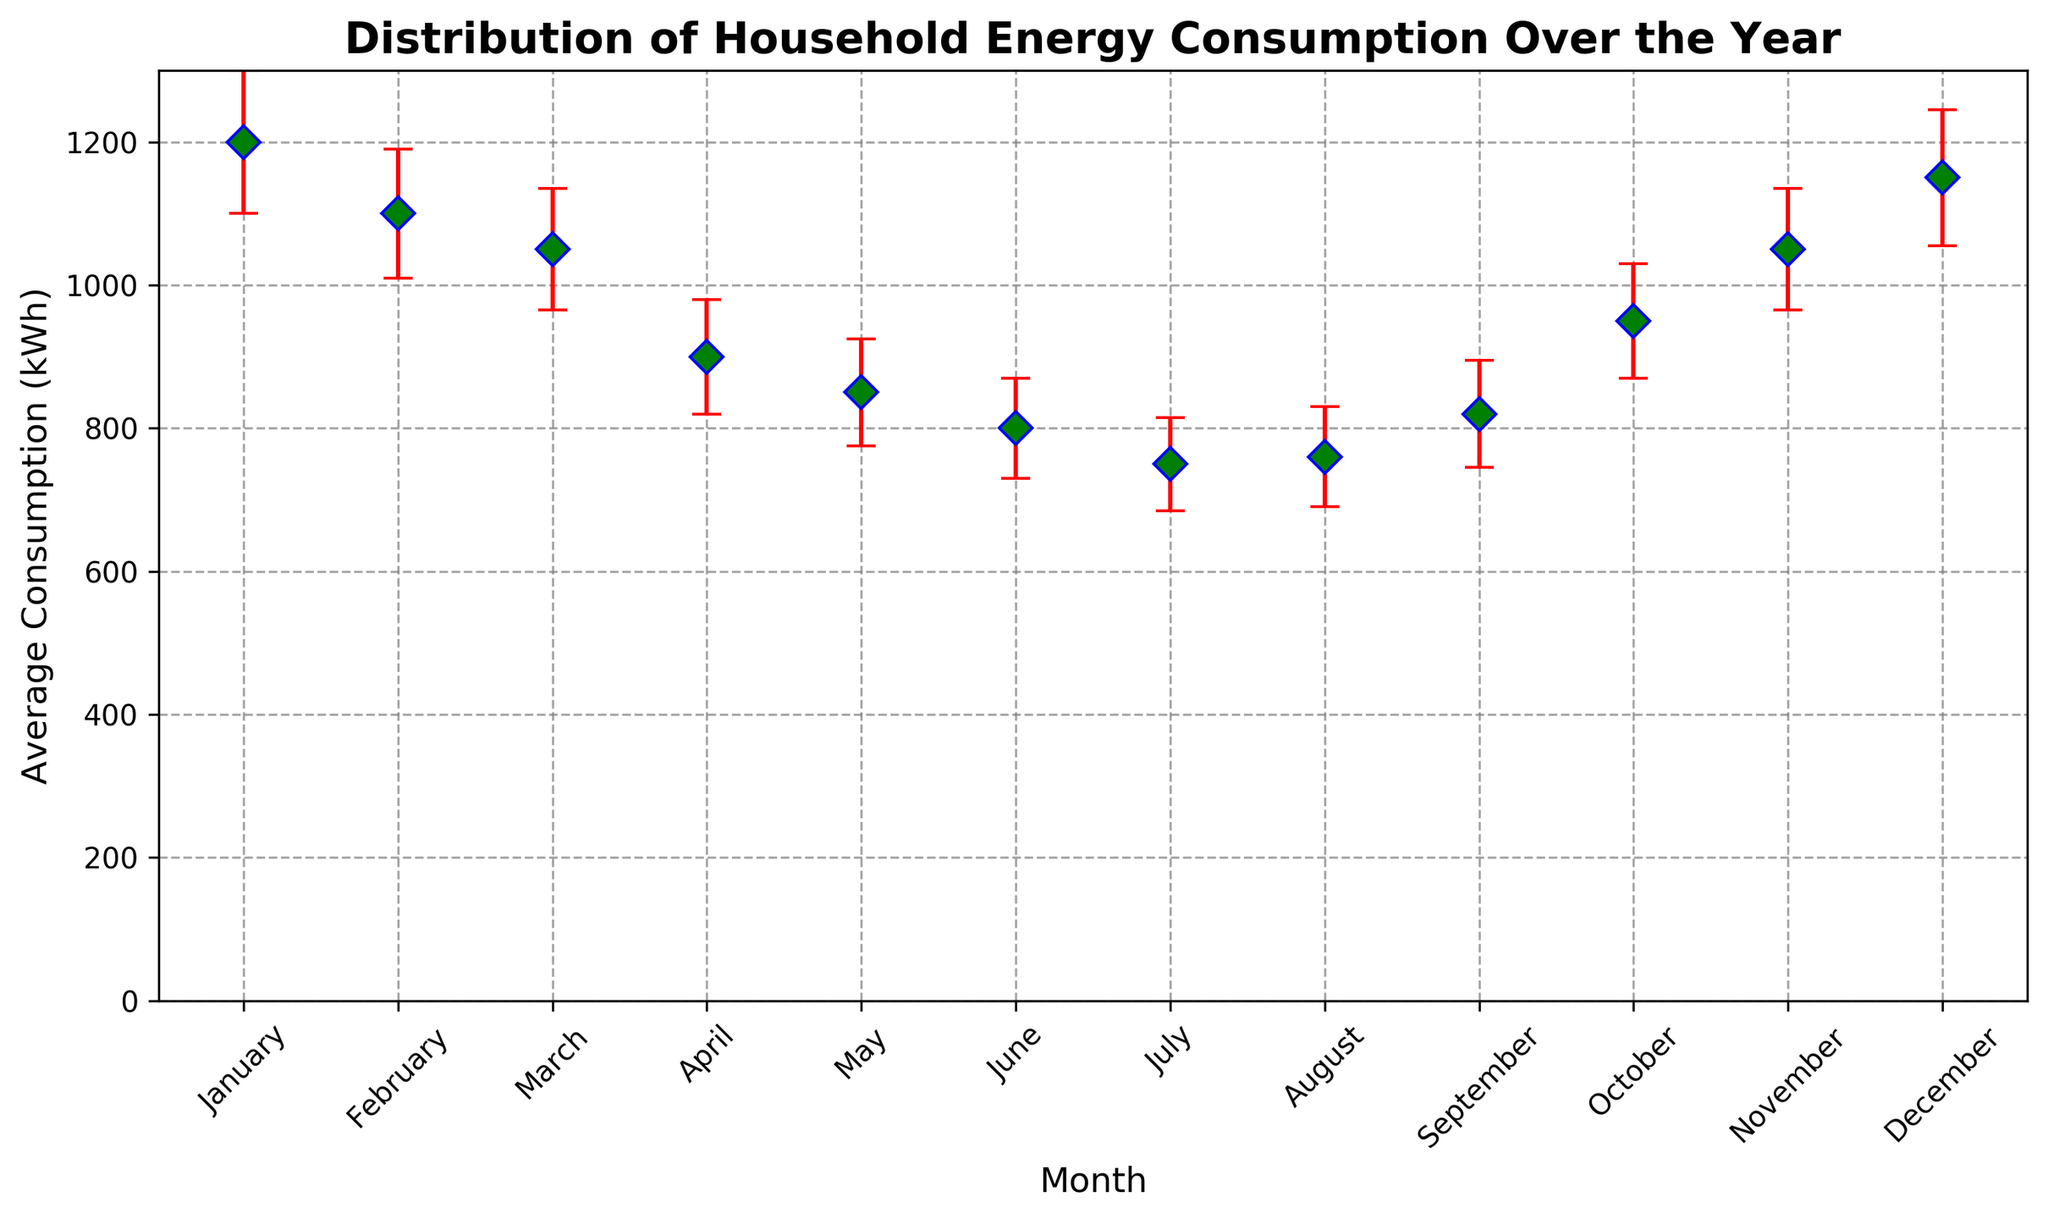What is the average energy consumption in January? The data point for January shows an average consumption of 1200 kWh.
Answer: 1200 kWh Which month has the lowest average energy consumption? When looking at the plotted points, July has the lowest average consumption at 750 kWh.
Answer: July How much higher is the consumption in December compared to June? The average consumption in December is 1150 kWh, and in June it is 800 kWh. The difference is 1150 - 800 = 350 kWh.
Answer: 350 kWh What is the overall trend in energy consumption from January to December? By visually examining the points, we see a high consumption in the colder months, a decline towards the summer months, and then a rise again as winter approaches.
Answer: Declines then rises What months have an average consumption greater than 1000 kWh? The months with points higher than or equal to 1000 kWh are January, February, November, and December.
Answer: January, February, November, December What are the error bars representing in the figure? The red vertical lines extending from each data point are the error bars, indicating the standard deviation for each month's average consumption.
Answer: Standard deviation Which month shows the highest variability in energy consumption? The month with the longest error bar represents the highest variability. According to the figure, January has the largest error bar of 100 kWh.
Answer: January If you sum the average consumption for the summer months (June, July, August), what is the total? For June (800 kWh), July (750 kWh), and August (760 kWh), the total is 800 + 750 + 760 = 2310 kWh.
Answer: 2310 kWh What is the likely reason for the peaks in energy consumption during January and December? Considering the colder weather in January and December, the peaks are likely due to increased heating usage during these months.
Answer: Increased heating usage Is there any month where the difference between the average consumption and standard deviation is less than 700 kWh? Subtracting the standard deviation from the average for each month, we find that in February (1100 - 90 = 1010), March (1050 - 85 = 965), and April (900 - 80 = 820) the values remain above 700 kWh. No month has a value below 700 kWh.
Answer: No 